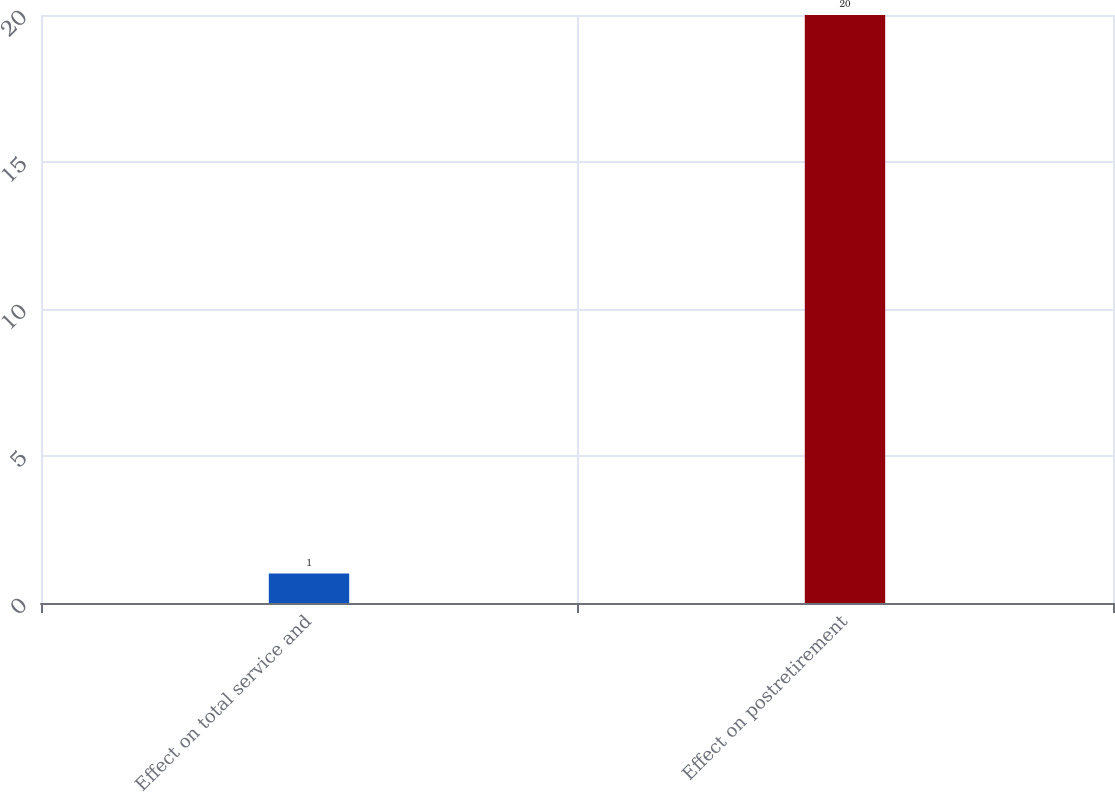Convert chart. <chart><loc_0><loc_0><loc_500><loc_500><bar_chart><fcel>Effect on total service and<fcel>Effect on postretirement<nl><fcel>1<fcel>20<nl></chart> 